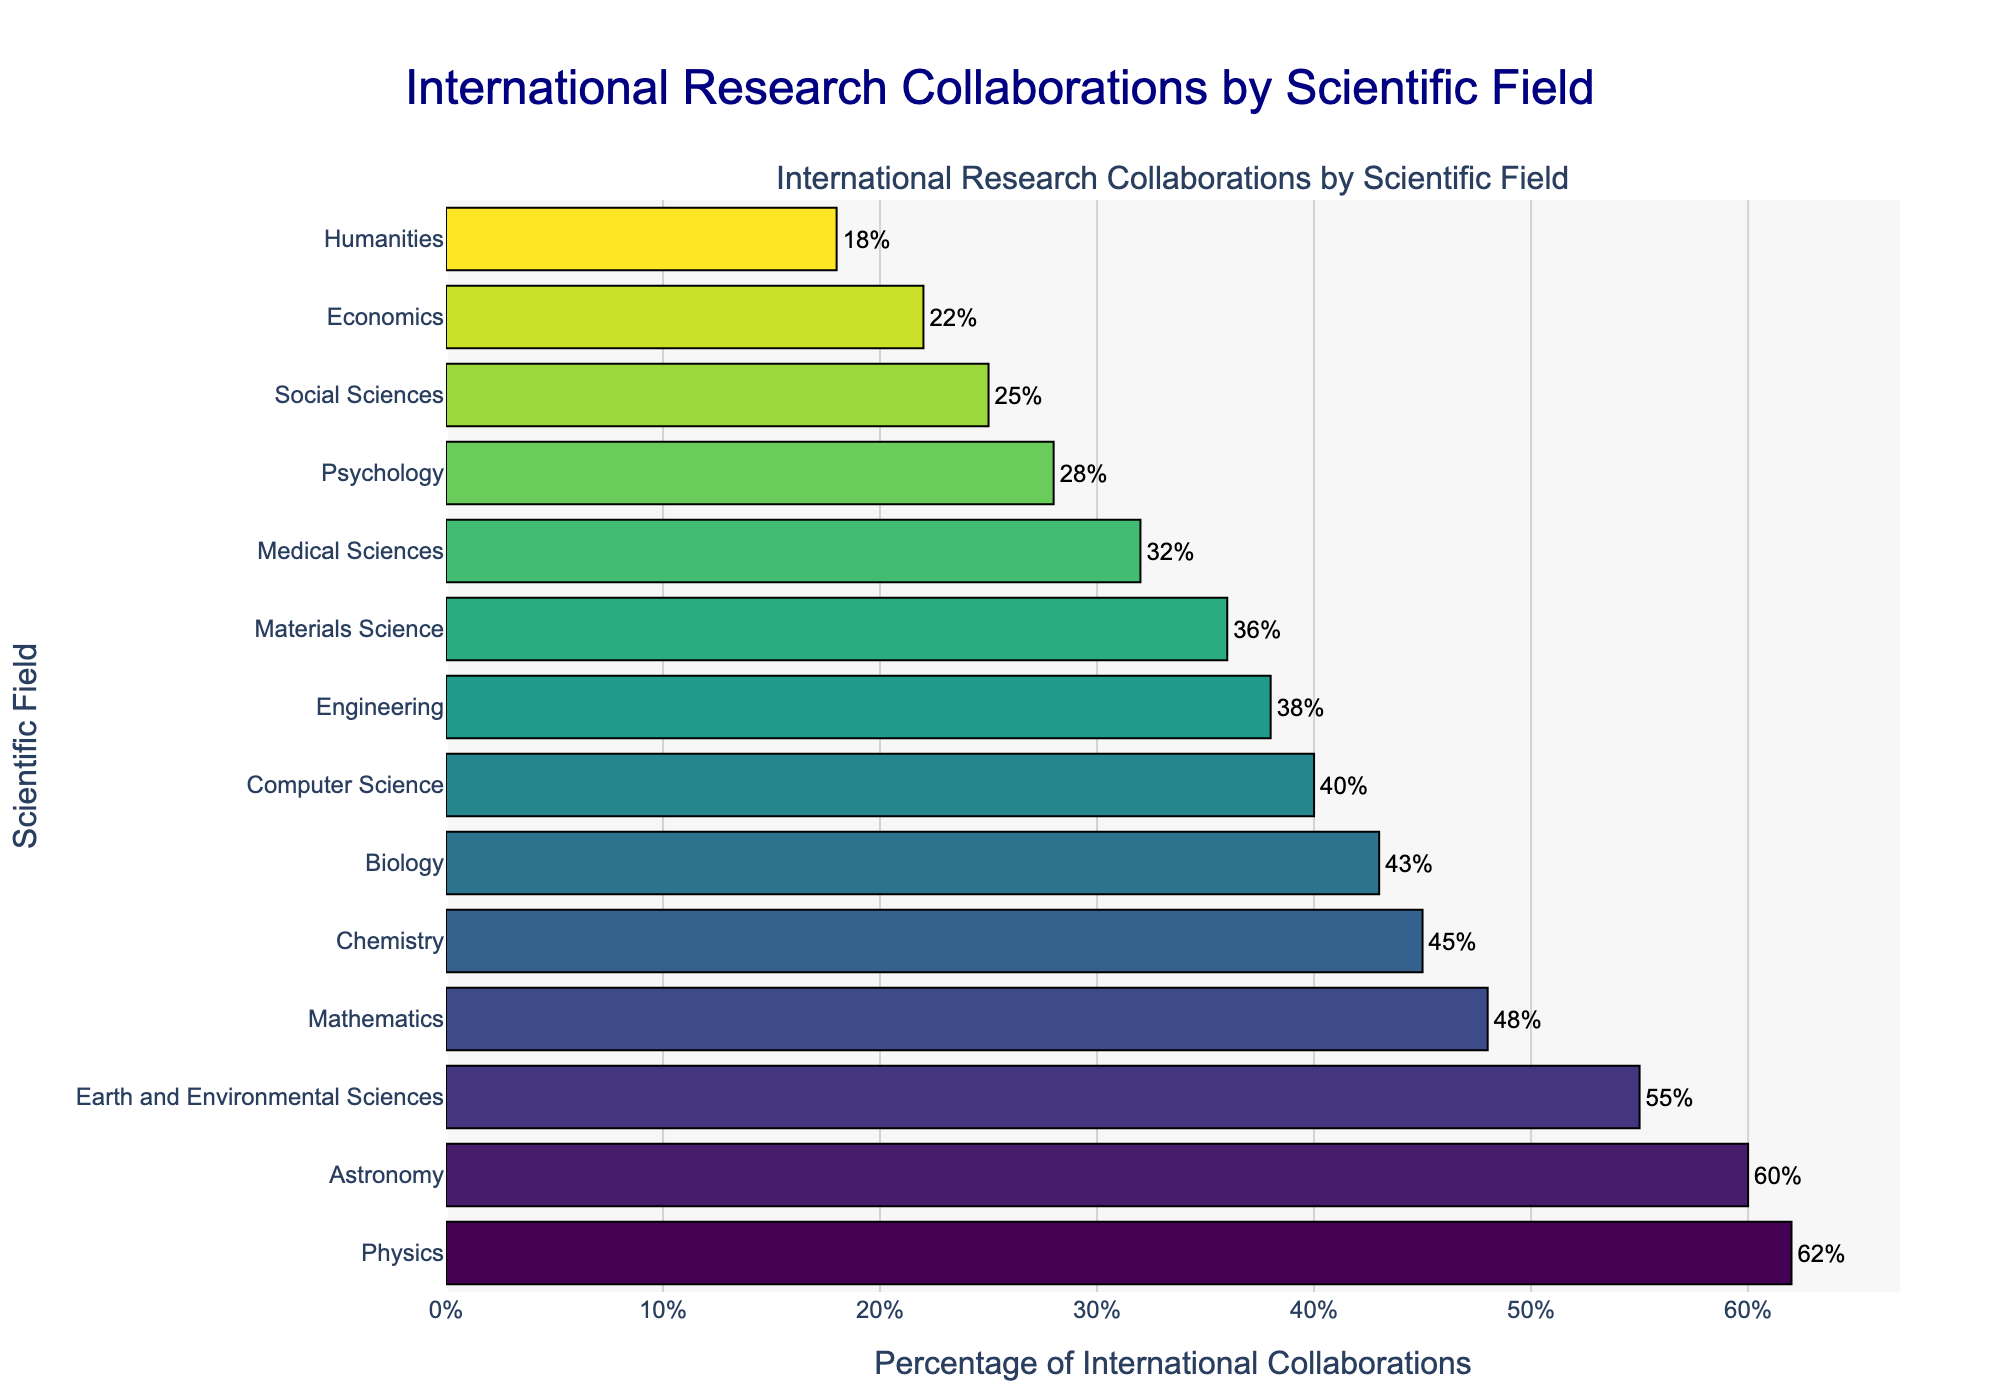Which scientific field has the highest percentage of international collaborations? To find the field with the highest percentage, look for the longest bar in the chart, which is positioned at the top due to the sorting. The field with the highest percentage of international collaborations is Physics.
Answer: Physics Which scientific field has the lowest percentage of international collaborations? To identify the field with the lowest percentage, look for the shortest bar at the bottom of the chart. The field with the lowest percentage of international collaborations is Humanities.
Answer: Humanities What is the percentage difference in international collaborations between Physics and Humanities? First, note the percentage of international collaborations for Physics, which is 62%. Then, note the percentage for Humanities, which is 18%. Subtract the percentage for Humanities from that of Physics to find the difference: 62% - 18% = 44%.
Answer: 44% Which fields have a percentage of international collaborations greater than 50%? Look for bars that extend beyond the 50% mark on the x-axis. The fields with greater than 50% international collaborations are Physics, Astronomy, and Earth and Environmental Sciences.
Answer: Physics, Astronomy, Earth and Environmental Sciences Are there more fields with less than 40% international collaborations or more than 40% international collaborations? Count the number of fields with bars extending less than 40% and those extending more than 40%. Fields with less than 40% are Computer Science, Engineering, Materials Science, Medical Sciences, Psychology, Social Sciences, Economics, and Humanities (8 fields). Fields with more than 40% are Physics, Astronomy, Earth and Environmental Sciences, Mathematics, Chemistry, and Biology (6 fields). There are more fields with less than 40% international collaborations.
Answer: Less than 40% What is the average percentage of international collaborations for the top 3 fields? Identify the top 3 fields: Physics (62%), Astronomy (60%), and Earth and Environmental Sciences (55%). Sum these percentages: 62 + 60 + 55 = 177, then divide by 3 to get the average: 177 / 3 ≈ 59%.
Answer: 59% Which field has a higher percentage of international collaborations, Chemistry or Mathematics? Locate the bars for Chemistry and Mathematics. Chemistry has 45% and Mathematics has 48%. Therefore, Mathematics has a higher percentage of international collaborations.
Answer: Mathematics What is the combined percentage of international collaborations for Social Sciences and Medical Sciences? Note the percentages for Social Sciences (25%) and Medical Sciences (32%). Add these percentages together: 25% + 32% = 57%.
Answer: 57% How many fields have a percentage of international collaborations between 30% and 50%? Identify the bars whose lengths fall between 30% and 50% on the x-axis. These fields are Mathematics (48%), Chemistry (45%), Biology (43%), Computer Science (40%), Medical Sciences (32%). There are 5 fields in this range.
Answer: 5 Which fields have international collaboration percentages closest to the average percentage of all fields? First, calculate the average percentage of all fields: Sum the percentages (62 + 60 + 55 + 48 + 45 + 43 + 40 + 38 + 36 + 32 + 28 + 25 + 22 + 18 = 554), then divide by the number of fields (14): 554 / 14 ≈ 39.6%. The closest fields are Computer Science with 40% and Engineering with 38%.
Answer: Computer Science, Engineering 